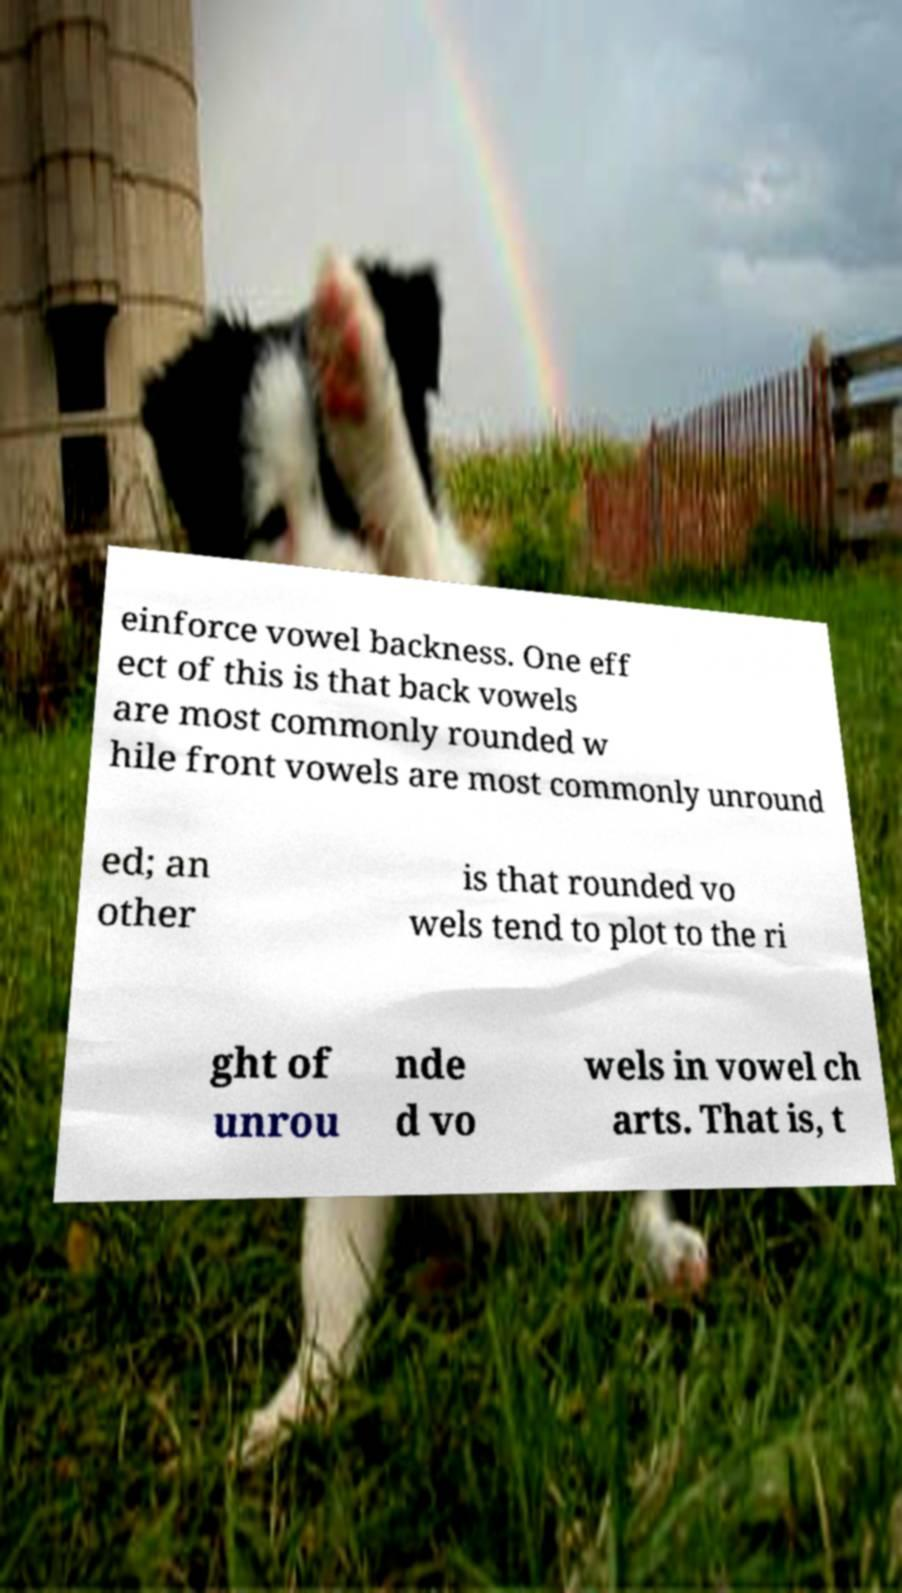Could you extract and type out the text from this image? einforce vowel backness. One eff ect of this is that back vowels are most commonly rounded w hile front vowels are most commonly unround ed; an other is that rounded vo wels tend to plot to the ri ght of unrou nde d vo wels in vowel ch arts. That is, t 